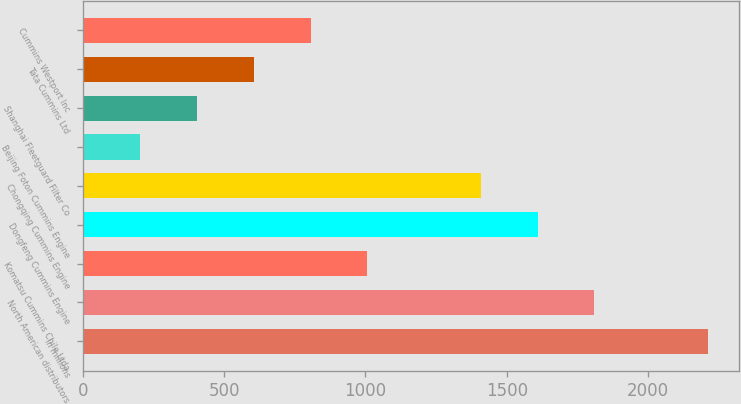Convert chart. <chart><loc_0><loc_0><loc_500><loc_500><bar_chart><fcel>In millions<fcel>North American distributors<fcel>Komatsu Cummins Chile Ltda<fcel>Dongfeng Cummins Engine<fcel>Chongqing Cummins Engine<fcel>Beijing Foton Cummins Engine<fcel>Shanghai Fleetguard Filter Co<fcel>Tata Cummins Ltd<fcel>Cummins Westport Inc<nl><fcel>2211.9<fcel>1810.1<fcel>1006.5<fcel>1609.2<fcel>1408.3<fcel>202.9<fcel>403.8<fcel>604.7<fcel>805.6<nl></chart> 